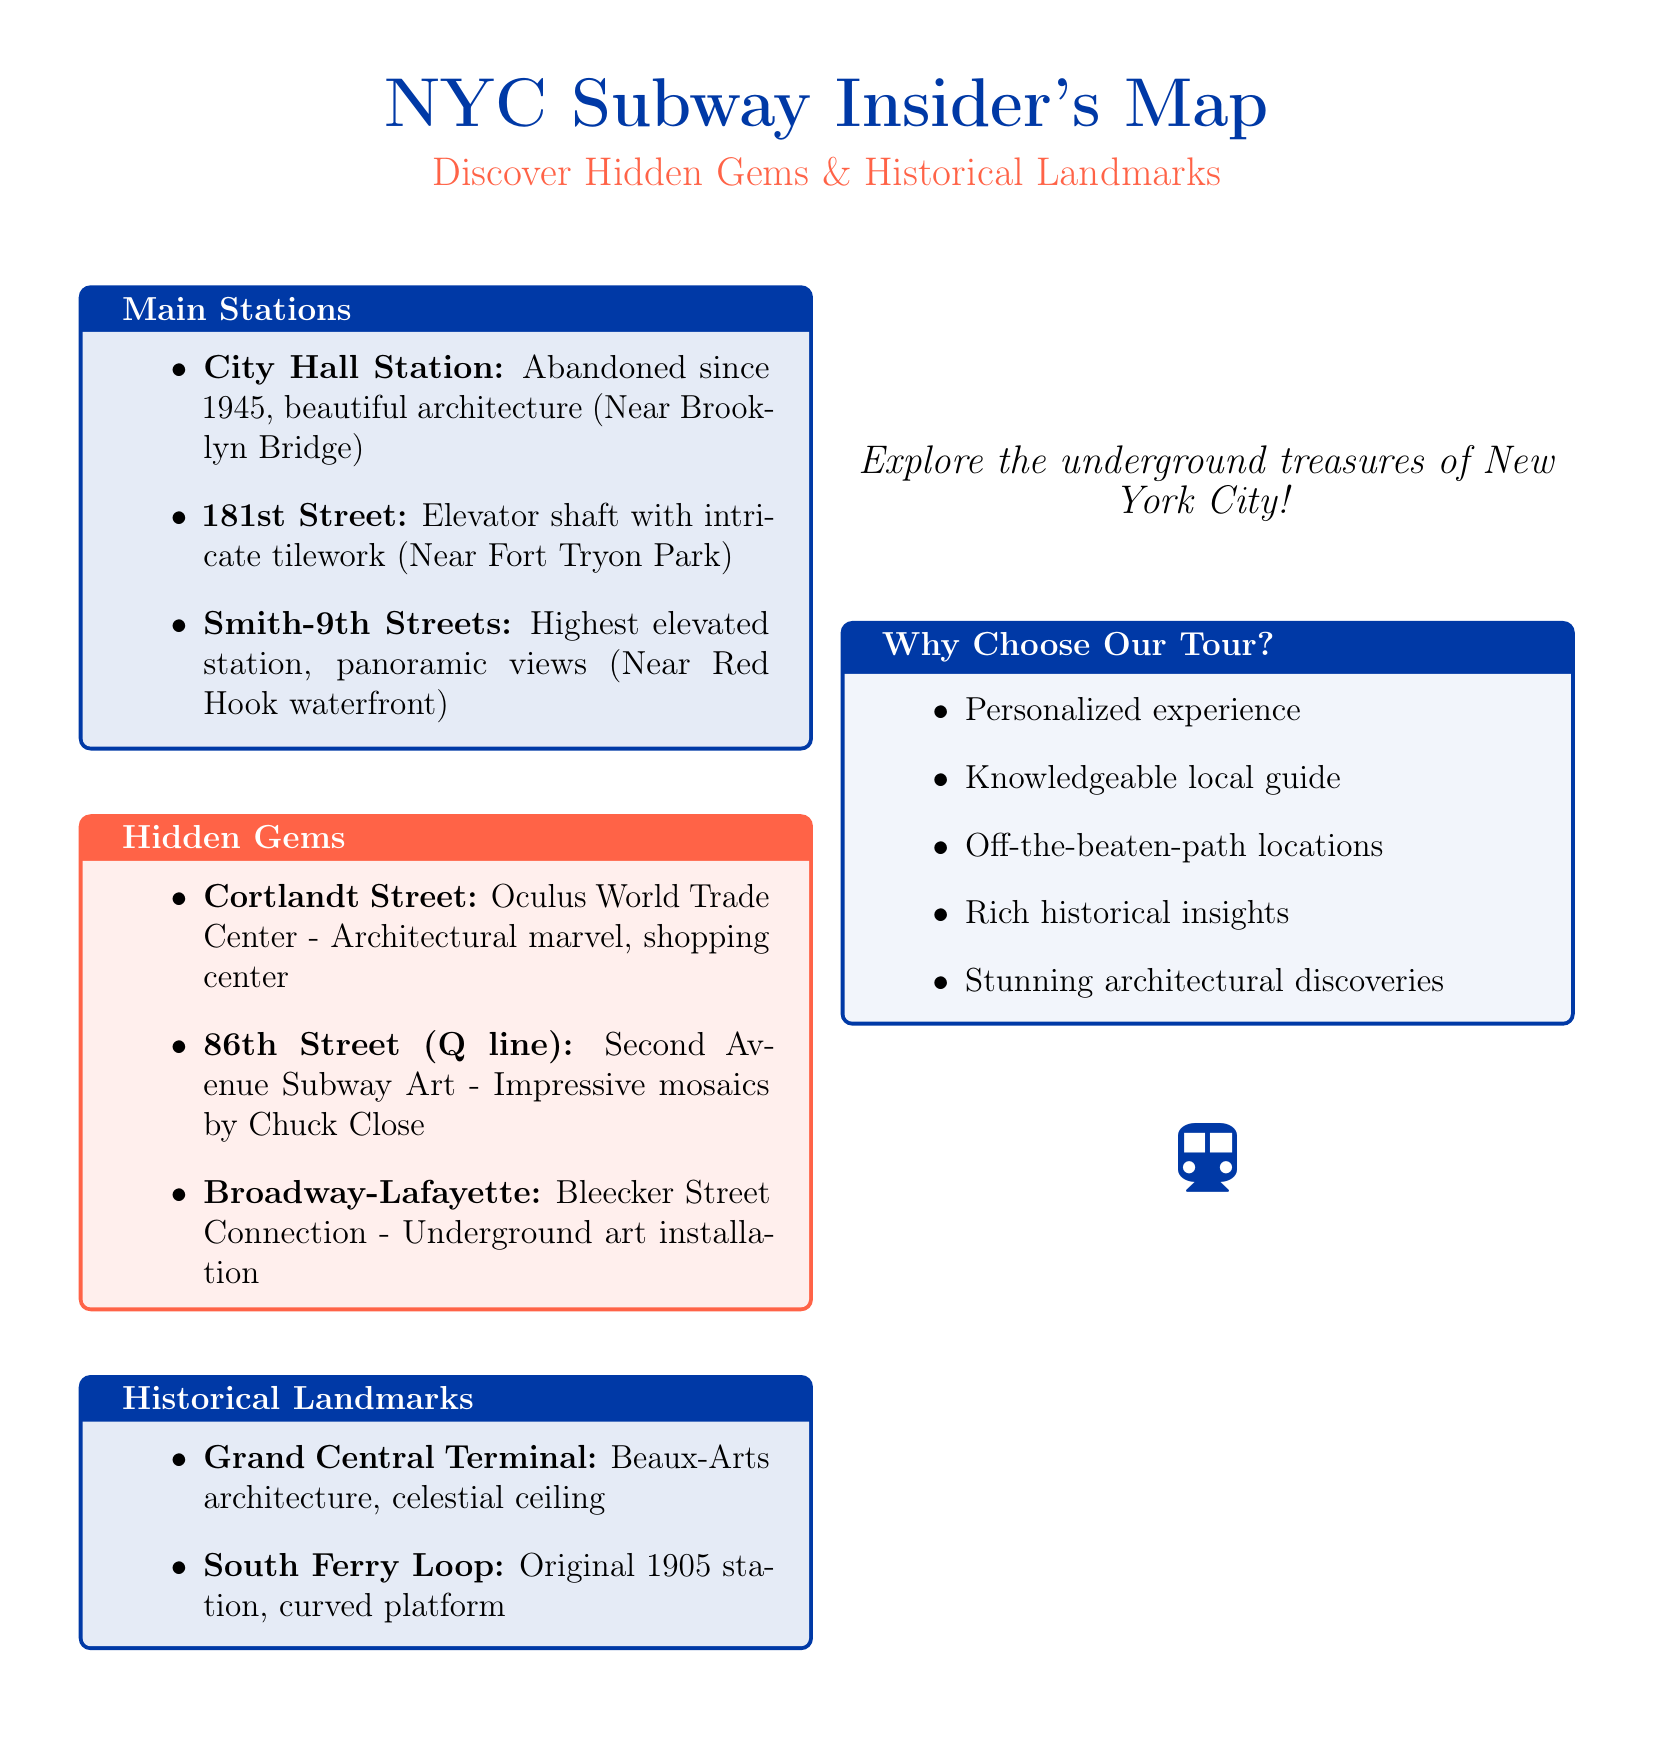What is the title of the map? The title of the map prominently displayed at the top is "NYC Subway Insider's Map."
Answer: NYC Subway Insider's Map Who is the guide for the tour? The guide's name is listed in the tour information section of the document.
Answer: Mike Sullivan What color highlights the hidden gems section? The color used to highlight the hidden gems section is indicated in the document's color coding.
Answer: Tomato How many main stations are listed? The number of main stations can be counted in the main stations section of the document.
Answer: 3 What unique feature is noted about 181st Street station? The document specifies a distinctive characteristic of the 181st Street station related to its design.
Answer: Elevator shaft with intricate tilework Which subway line is associated with 86th Street? The line number mentioned in the document for the 86th Street station indicates the specific subway line.
Answer: Q line What architectural feature is associated with Grand Central Terminal? The document describes an architectural element that is a prominent feature of Grand Central Terminal.
Answer: Celestial ceiling What does the tour offer that stands out compared to others? The document highlights a specific aspect of the tour that makes it preferable.
Answer: Personalized experience What is the phone number for Mike Sullivan? The phone number is provided in the tour information section for contacting the guide.
Answer: 212-555-1234 